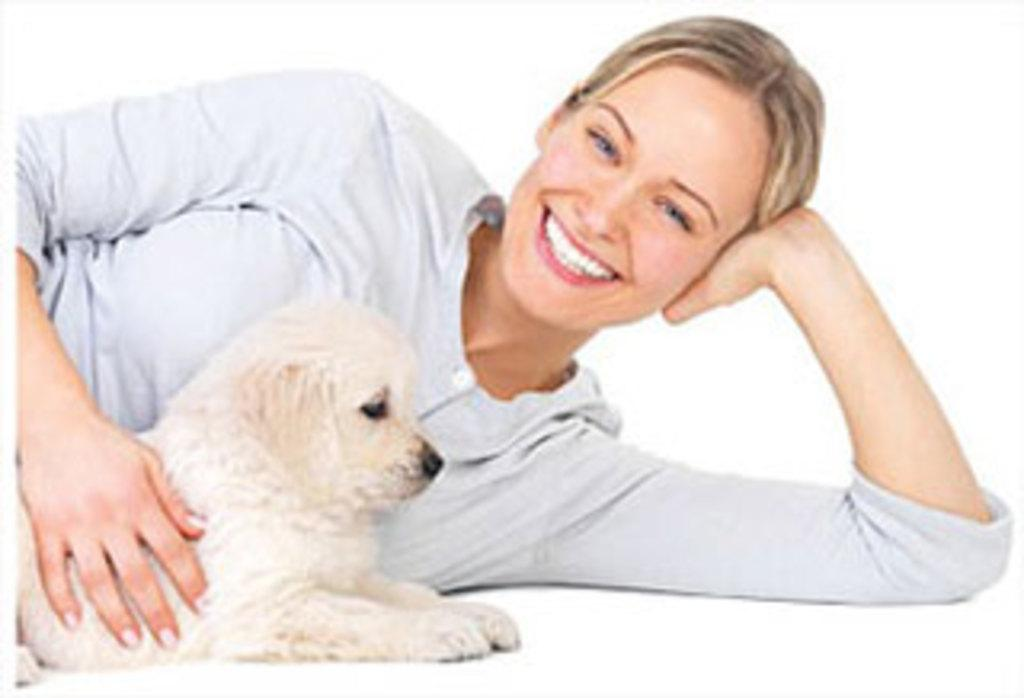What animal is on the left side of the image? There is a dog on the left side of the image. Who is lying beside the dog? A lady is lying beside the dog. What expression does the lady have? The lady is smiling. What type of wristwatch is the dog wearing in the image? There is no wristwatch present in the image, as dogs do not wear wristwatches. 